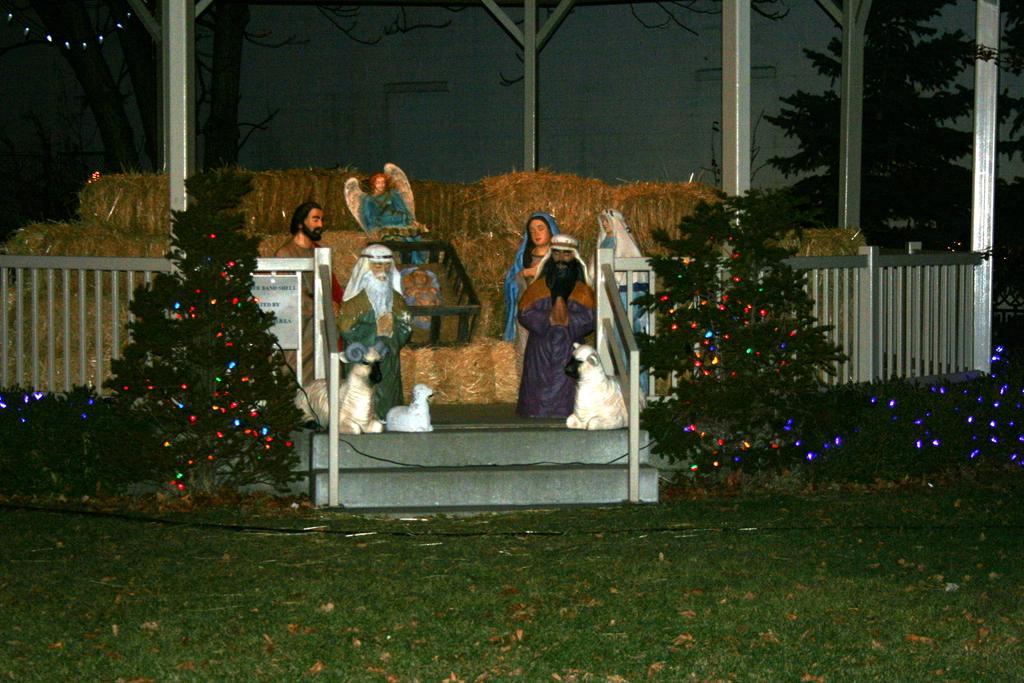How would you summarize this image in a sentence or two? In this picture we can see few sculptures, in front of the sculptures we can find fence, metal rods and few trees, and also we can find few lights on the trees. 